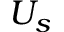<formula> <loc_0><loc_0><loc_500><loc_500>U _ { s }</formula> 